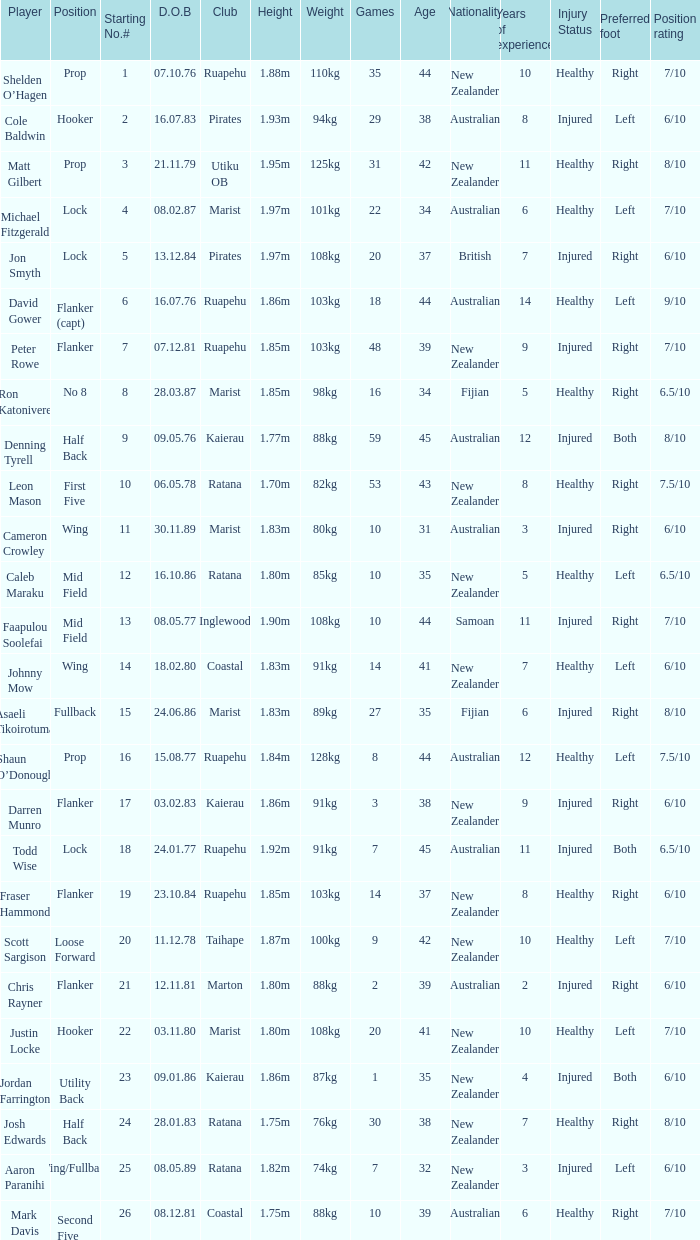What position does the player Todd Wise play in? Lock. 